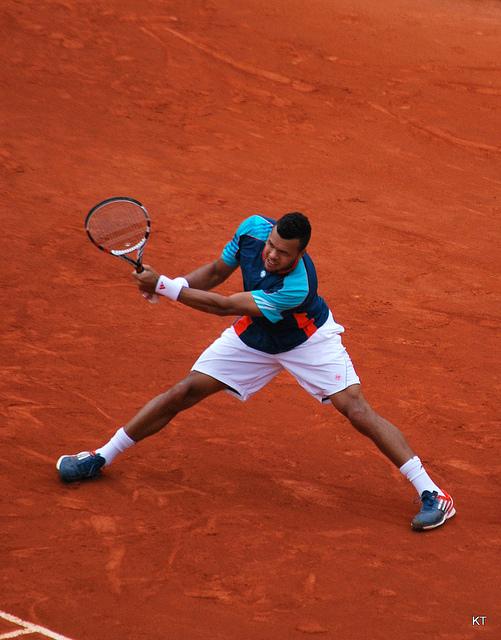What is he doing?
Give a very brief answer. Playing tennis. How is he standing?
Short answer required. Stretched out. What color is the ground?
Short answer required. Orange. 